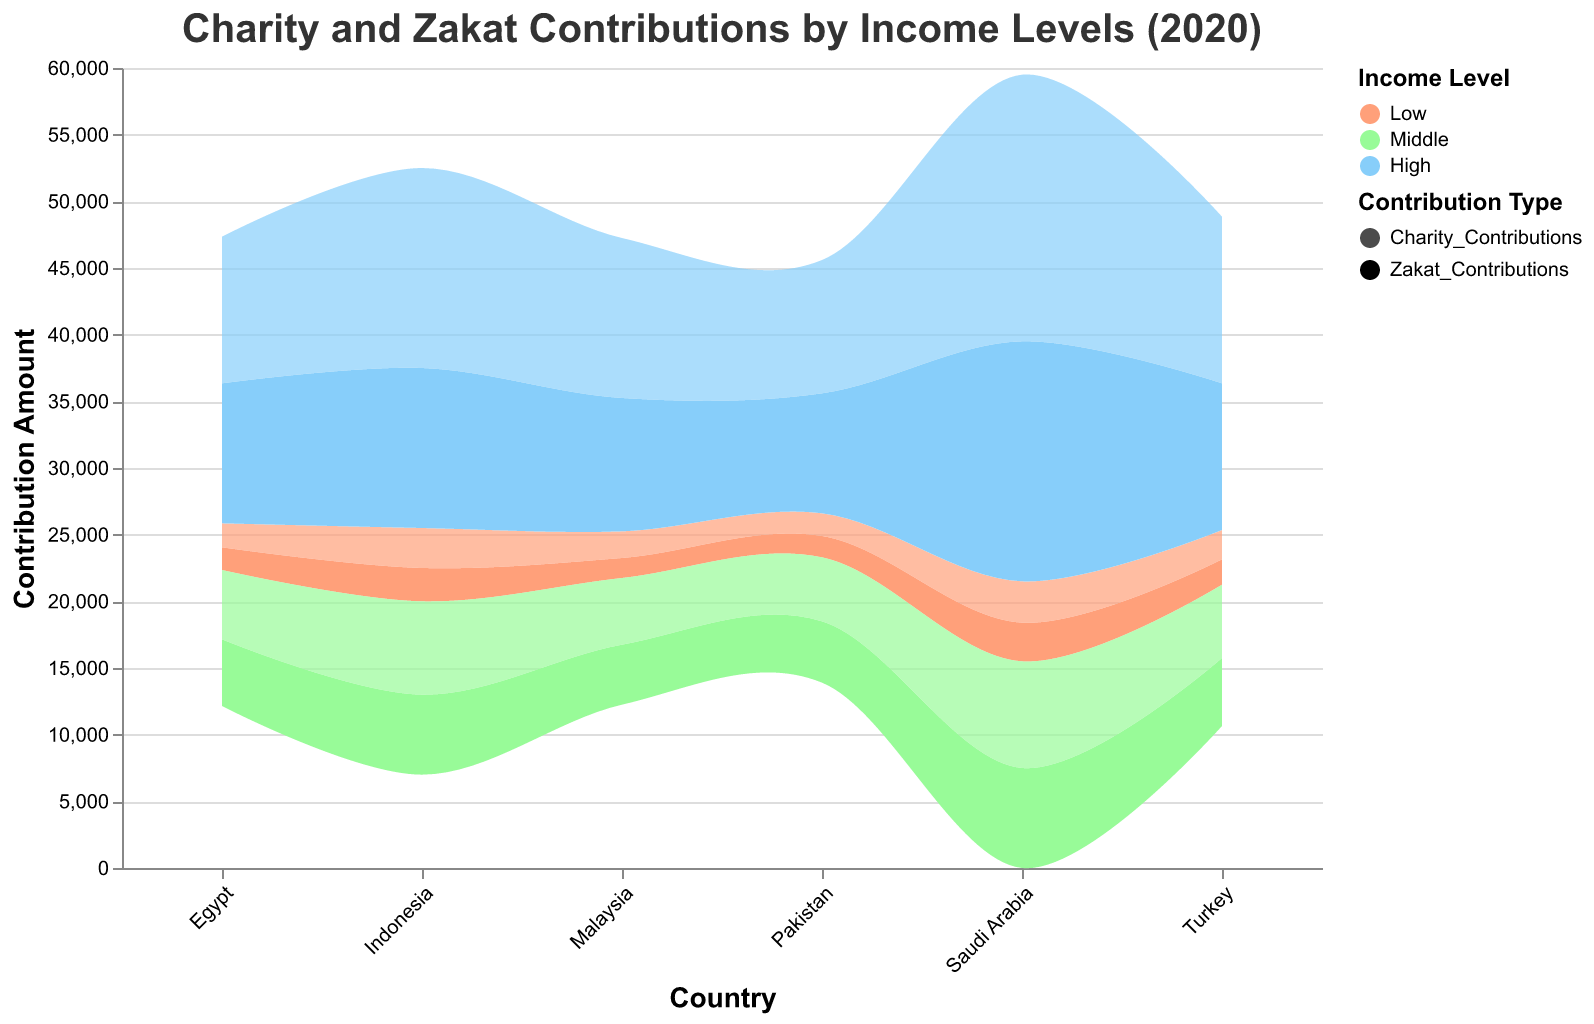What are the countries featured in the chart? The x-axis of the chart is labeled "Country," which lists all the countries featured. By examining the labels, we can identify the countries.
Answer: Malaysia, Egypt, Indonesia, Turkey, Pakistan, Saudi Arabia Which country shows the highest Zakat contribution for the High-income level? To find this, look at the highest point for Zakat Contributions in the High-income level category for each country. Saudi Arabia's High-income segment has the maximum value.
Answer: Saudi Arabia What is the charity contribution amount for Middle-income levels in Egypt and Turkey? Find and compare the heights of the Middle-income segments for Charity Contributions in Egypt and Turkey by following their respective values in the chart. Egypt has a contribution of 5200, and Turkey has 5500.
Answer: Egypt: 5200, Turkey: 5500 Between Malaysia and Pakistan, which country has higher Zakat contributions for the Low-income level? Locate the Low-income Zakat contribution segments for Malaysia and Pakistan on the chart. Compare their heights to see which is higher. Malaysia's contribution is 1500, and Pakistan's is 1600.
Answer: Pakistan How does Indonesia's Charity contribution for Middle-income compare to Saudi Arabia's for Middle-income? Identify and compare the charity contribution values for Middle-income levels in Indonesia and Saudi Arabia using their positions on the chart. Indonesia contributes 7000, and Saudi Arabia contributes 8000.
Answer: Indonesia: 7000, Saudi Arabia: 8000 What is the total Zakat contribution for all income levels in Saudi Arabia? Sum the Zakat contributions for Low, Middle, and High-income levels in Saudi Arabia by adding their values together: 2900 (Low) + 7500 (Middle) + 18000 (High) = 28400.
Answer: 28400 Which country has the smallest difference between Charity and Zakat contributions for the High-income level? For each country, calculate the difference between Charity and Zakat contributions in the High-income level, then identify the smallest difference among them. Malaysia: 2000, Egypt: 500, Indonesia: 3000, Turkey: 1500, Pakistan: 1000, Saudi Arabia: 2000. Egypt has the smallest difference.
Answer: Egypt Which income level appears to have the highest variability in contributions within a single country? Variability within a country can be observed by comparing the range (difference between Charity and Zakat) across Low, Middle, and High-income levels for one country. Look for the highest difference in any country's income levels. Saudi Arabia shows high variability: Low: 200, Middle: 500, High: 2000
Answer: High How does the distribution of contributions in Indonesia's High-income level compare between Charity and Zakat? Examine the relative heights of Charity and Zakat contributions for Indonesia's High-income level segment. Charity contributions (15000) are higher than Zakat contributions (12000), showing a significant difference.
Answer: Charity: 15000, Zakat: 12000 Which contribution type shows more consistency across all income levels for Pakistan? Compare the consistency of the heights of segments for Charity and Zakat contributions in Pakistan across Low, Middle, and High-income levels. Zakat contributions are more consistent: 1600 (Low), 4600 (Middle), 9000 (High), compared to Charity: 1700 (Low), 4800 (Middle), 10000 (High)
Answer: Zakat 